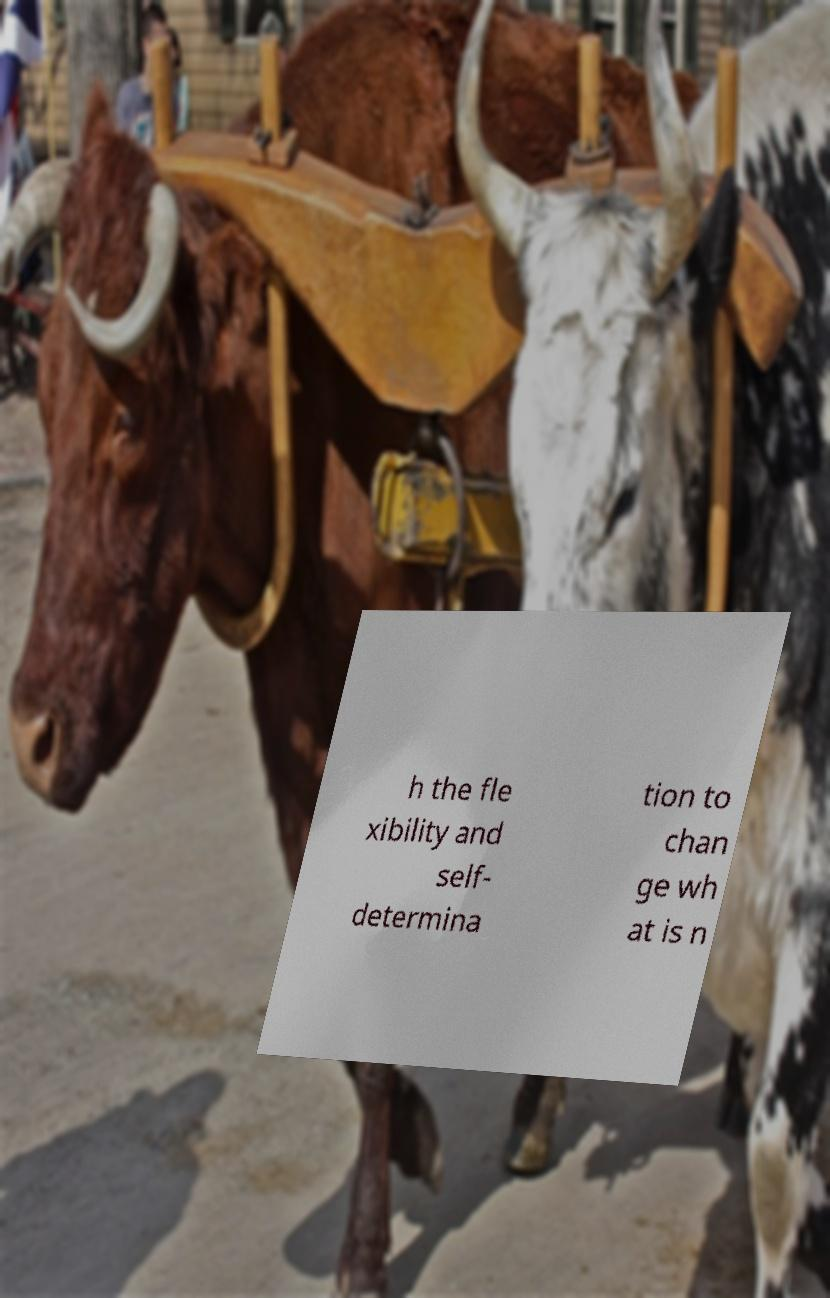Please read and relay the text visible in this image. What does it say? h the fle xibility and self- determina tion to chan ge wh at is n 